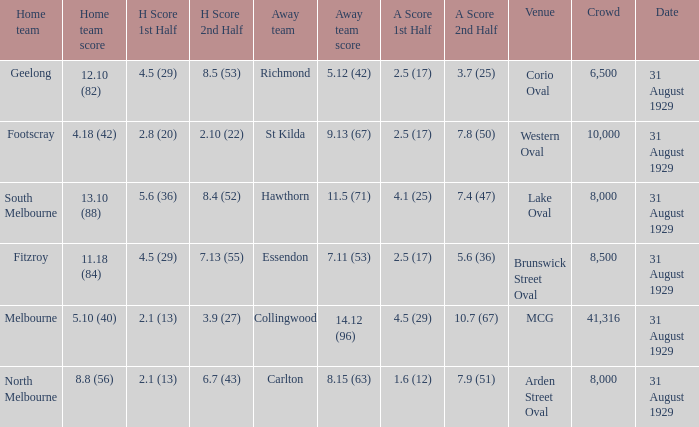What date was the game when the away team was carlton? 31 August 1929. 